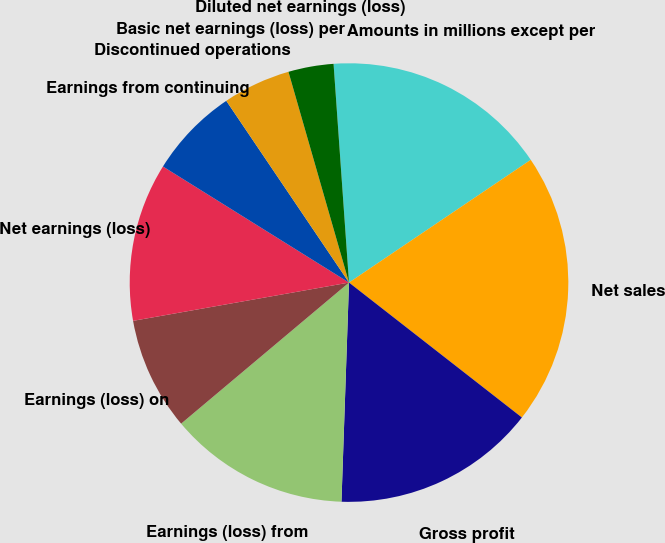Convert chart. <chart><loc_0><loc_0><loc_500><loc_500><pie_chart><fcel>Amounts in millions except per<fcel>Net sales<fcel>Gross profit<fcel>Earnings (loss) from<fcel>Earnings (loss) on<fcel>Net earnings (loss)<fcel>Earnings from continuing<fcel>Discontinued operations<fcel>Basic net earnings (loss) per<fcel>Diluted net earnings (loss)<nl><fcel>16.67%<fcel>20.0%<fcel>15.0%<fcel>13.33%<fcel>8.33%<fcel>11.67%<fcel>6.67%<fcel>0.0%<fcel>5.0%<fcel>3.33%<nl></chart> 